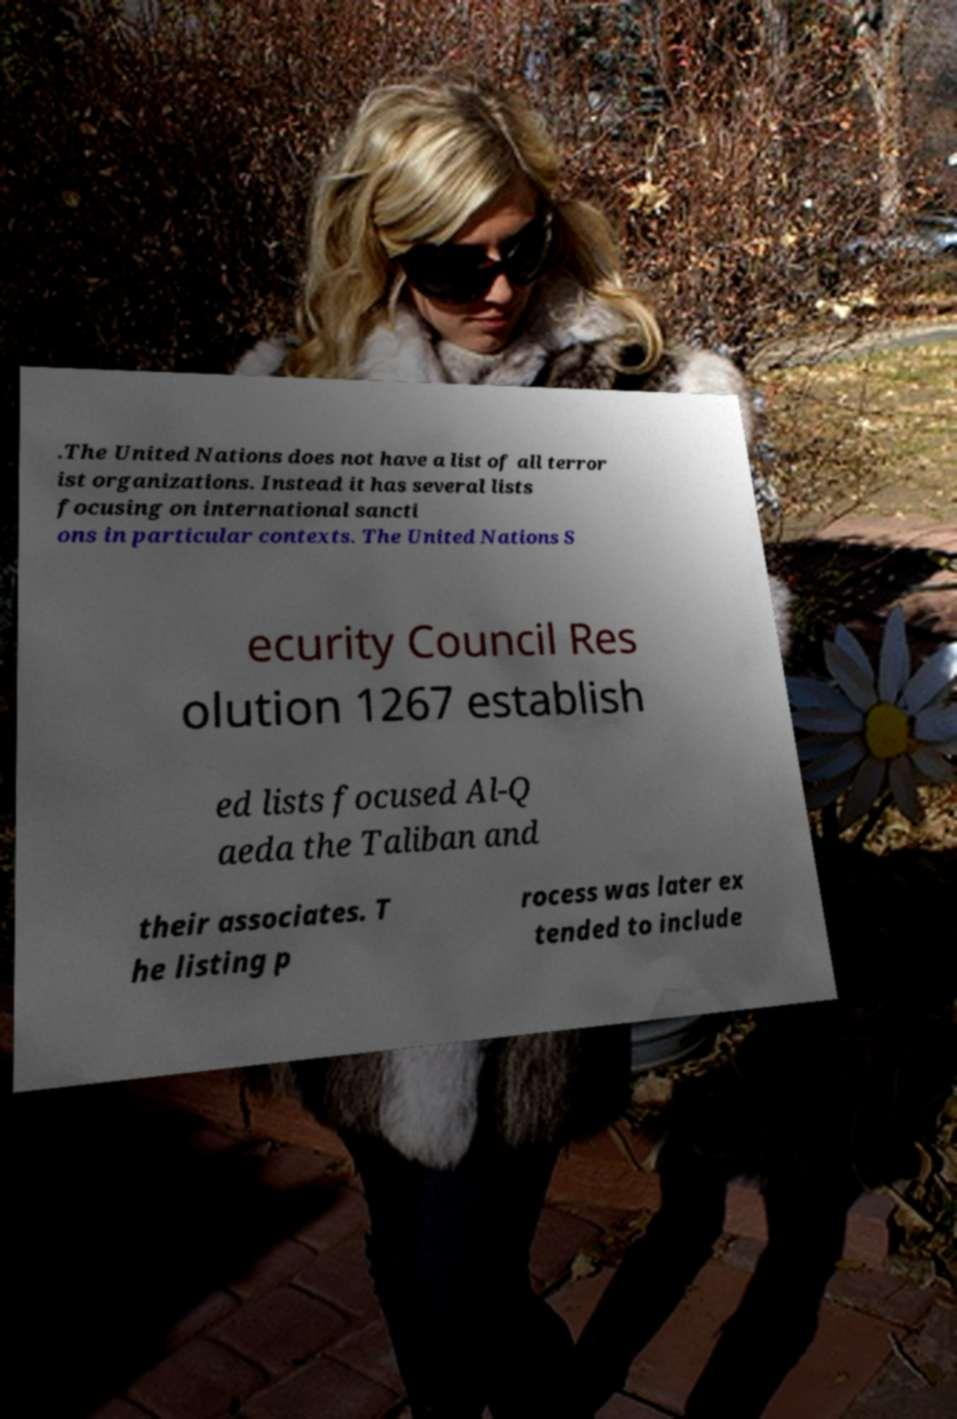For documentation purposes, I need the text within this image transcribed. Could you provide that? .The United Nations does not have a list of all terror ist organizations. Instead it has several lists focusing on international sancti ons in particular contexts. The United Nations S ecurity Council Res olution 1267 establish ed lists focused Al-Q aeda the Taliban and their associates. T he listing p rocess was later ex tended to include 